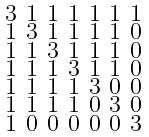<formula> <loc_0><loc_0><loc_500><loc_500>\begin{smallmatrix} 3 & 1 & 1 & 1 & 1 & 1 & 1 \\ 1 & 3 & 1 & 1 & 1 & 1 & 0 \\ 1 & 1 & 3 & 1 & 1 & 1 & 0 \\ 1 & 1 & 1 & 3 & 1 & 1 & 0 \\ 1 & 1 & 1 & 1 & 3 & 0 & 0 \\ 1 & 1 & 1 & 1 & 0 & 3 & 0 \\ 1 & 0 & 0 & 0 & 0 & 0 & 3 \end{smallmatrix}</formula> 